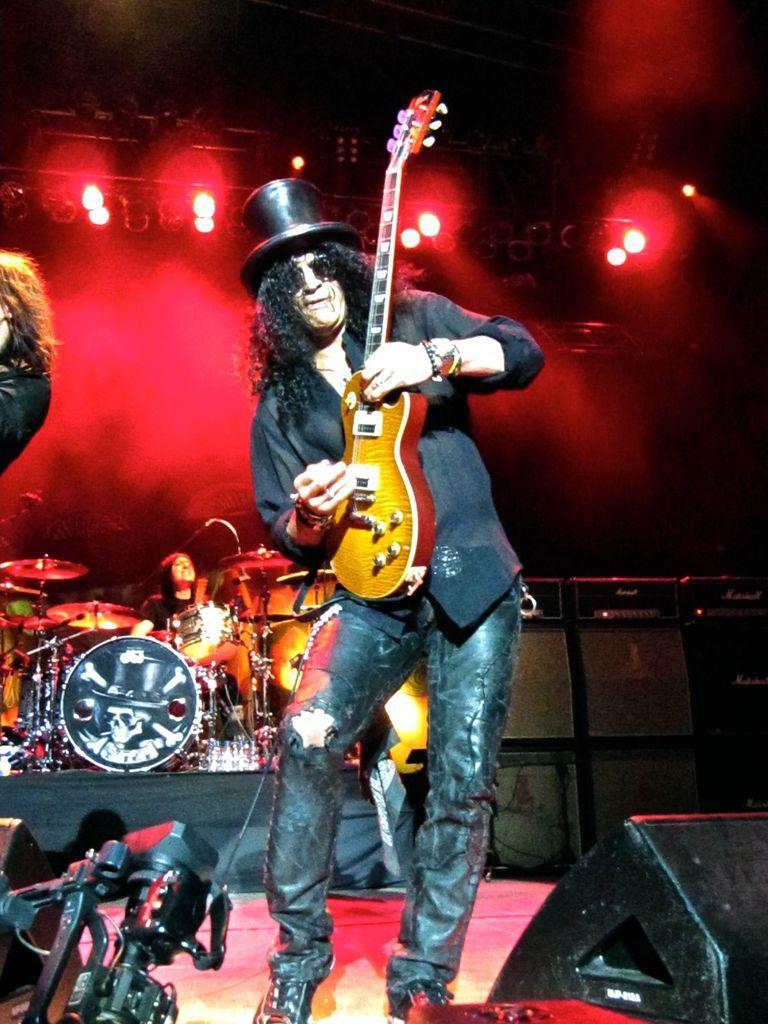Could you give a brief overview of what you see in this image? This image is clicked in a concert, there are three persons on the dais. In the front, the man wearing black dress is playing a guitar. In the background, there is a person playing drums. In the background, there are lights in red color. At the bottom right, there is a speaker. At the bottom left, there is a camera. 